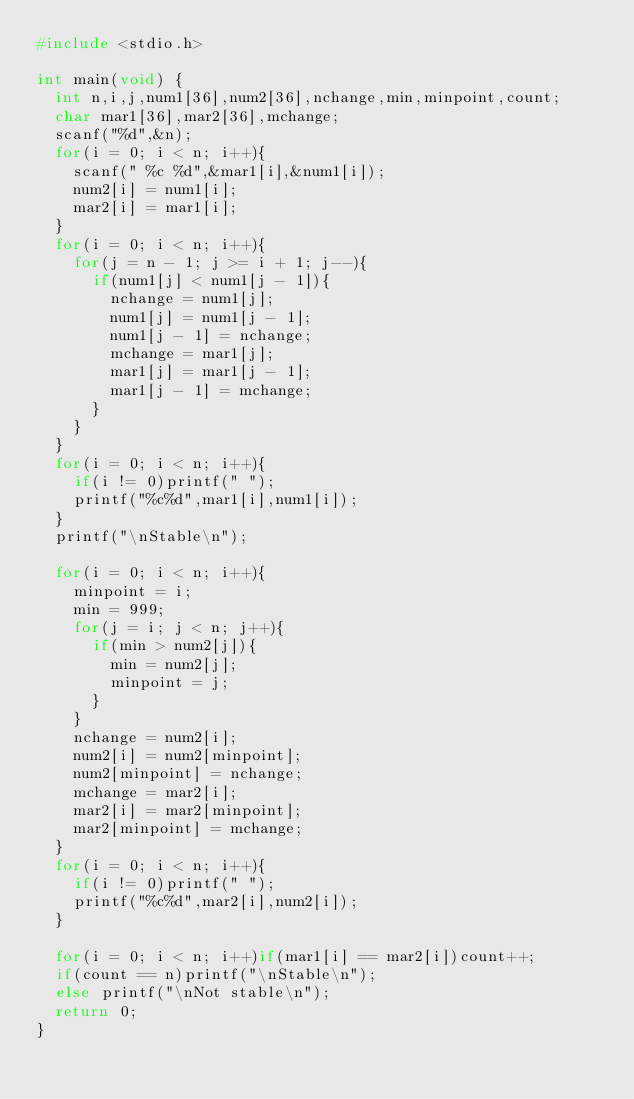Convert code to text. <code><loc_0><loc_0><loc_500><loc_500><_C_>#include <stdio.h>

int main(void) {
  int n,i,j,num1[36],num2[36],nchange,min,minpoint,count;
  char mar1[36],mar2[36],mchange;
  scanf("%d",&n);
  for(i = 0; i < n; i++){
    scanf(" %c %d",&mar1[i],&num1[i]);
    num2[i] = num1[i];
    mar2[i] = mar1[i];
  }
  for(i = 0; i < n; i++){
    for(j = n - 1; j >= i + 1; j--){
      if(num1[j] < num1[j - 1]){
        nchange = num1[j];
        num1[j] = num1[j - 1];
        num1[j - 1] = nchange;
        mchange = mar1[j];
        mar1[j] = mar1[j - 1];
        mar1[j - 1] = mchange;
      }
    }
  }
  for(i = 0; i < n; i++){
    if(i != 0)printf(" ");
    printf("%c%d",mar1[i],num1[i]);
  }
  printf("\nStable\n");

  for(i = 0; i < n; i++){
    minpoint = i;
    min = 999;
    for(j = i; j < n; j++){
      if(min > num2[j]){
        min = num2[j];
        minpoint = j;
      }
    }
    nchange = num2[i];
    num2[i] = num2[minpoint];
    num2[minpoint] = nchange;
    mchange = mar2[i];
    mar2[i] = mar2[minpoint];
    mar2[minpoint] = mchange;
  }
  for(i = 0; i < n; i++){
    if(i != 0)printf(" ");
    printf("%c%d",mar2[i],num2[i]);
  }

  for(i = 0; i < n; i++)if(mar1[i] == mar2[i])count++;
  if(count == n)printf("\nStable\n");
  else printf("\nNot stable\n");
  return 0;
}
</code> 